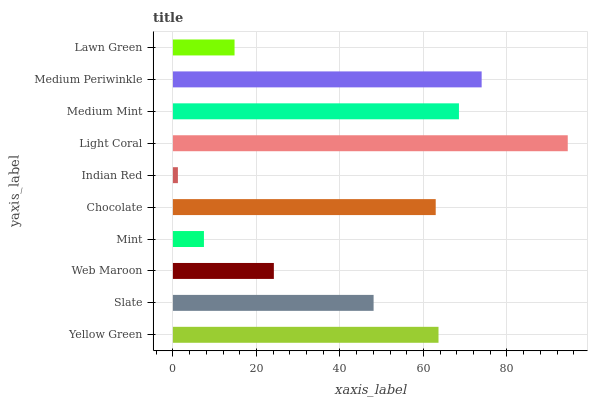Is Indian Red the minimum?
Answer yes or no. Yes. Is Light Coral the maximum?
Answer yes or no. Yes. Is Slate the minimum?
Answer yes or no. No. Is Slate the maximum?
Answer yes or no. No. Is Yellow Green greater than Slate?
Answer yes or no. Yes. Is Slate less than Yellow Green?
Answer yes or no. Yes. Is Slate greater than Yellow Green?
Answer yes or no. No. Is Yellow Green less than Slate?
Answer yes or no. No. Is Chocolate the high median?
Answer yes or no. Yes. Is Slate the low median?
Answer yes or no. Yes. Is Web Maroon the high median?
Answer yes or no. No. Is Medium Periwinkle the low median?
Answer yes or no. No. 